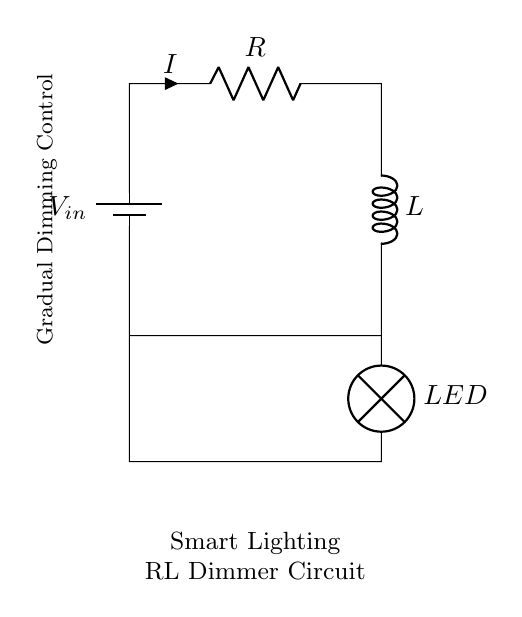What is the output component in this circuit? The output component is the LED, which is connected at the bottom of the circuit. LEDs are typically used in lighting applications.
Answer: LED What type of circuit is this? This is an RL circuit because it contains a resistor (R) and an inductor (L) connected in series. Such circuits are used for gradual changes in current which is suitable for dimming applications.
Answer: RL circuit What does the inductor do in this circuit? The inductor helps in smoothing the current flow and provides a gradual increase or decrease in current, which is essential for achieving the dimming effect in lighting.
Answer: Smooth current What is the purpose of the resistor in this circuit? The resistor limits the current flowing through the circuit, which helps to control the brightness of the LED when it dims gradually.
Answer: Current limitation What is the function labeled in the circuit diagram? The function labeled in the circuit is "Gradual Dimming Control," indicating that this circuit is designed to regulate the dimming of the LED over time.
Answer: Gradual Dimming Control What happens when the input voltage is increased? Increasing the input voltage increases the current flowing through the circuit, which will make the LED brighter, but the inductor will counteract the sudden changes, leading to a gradual increase instead of an immediate one.
Answer: LED brightness increases 